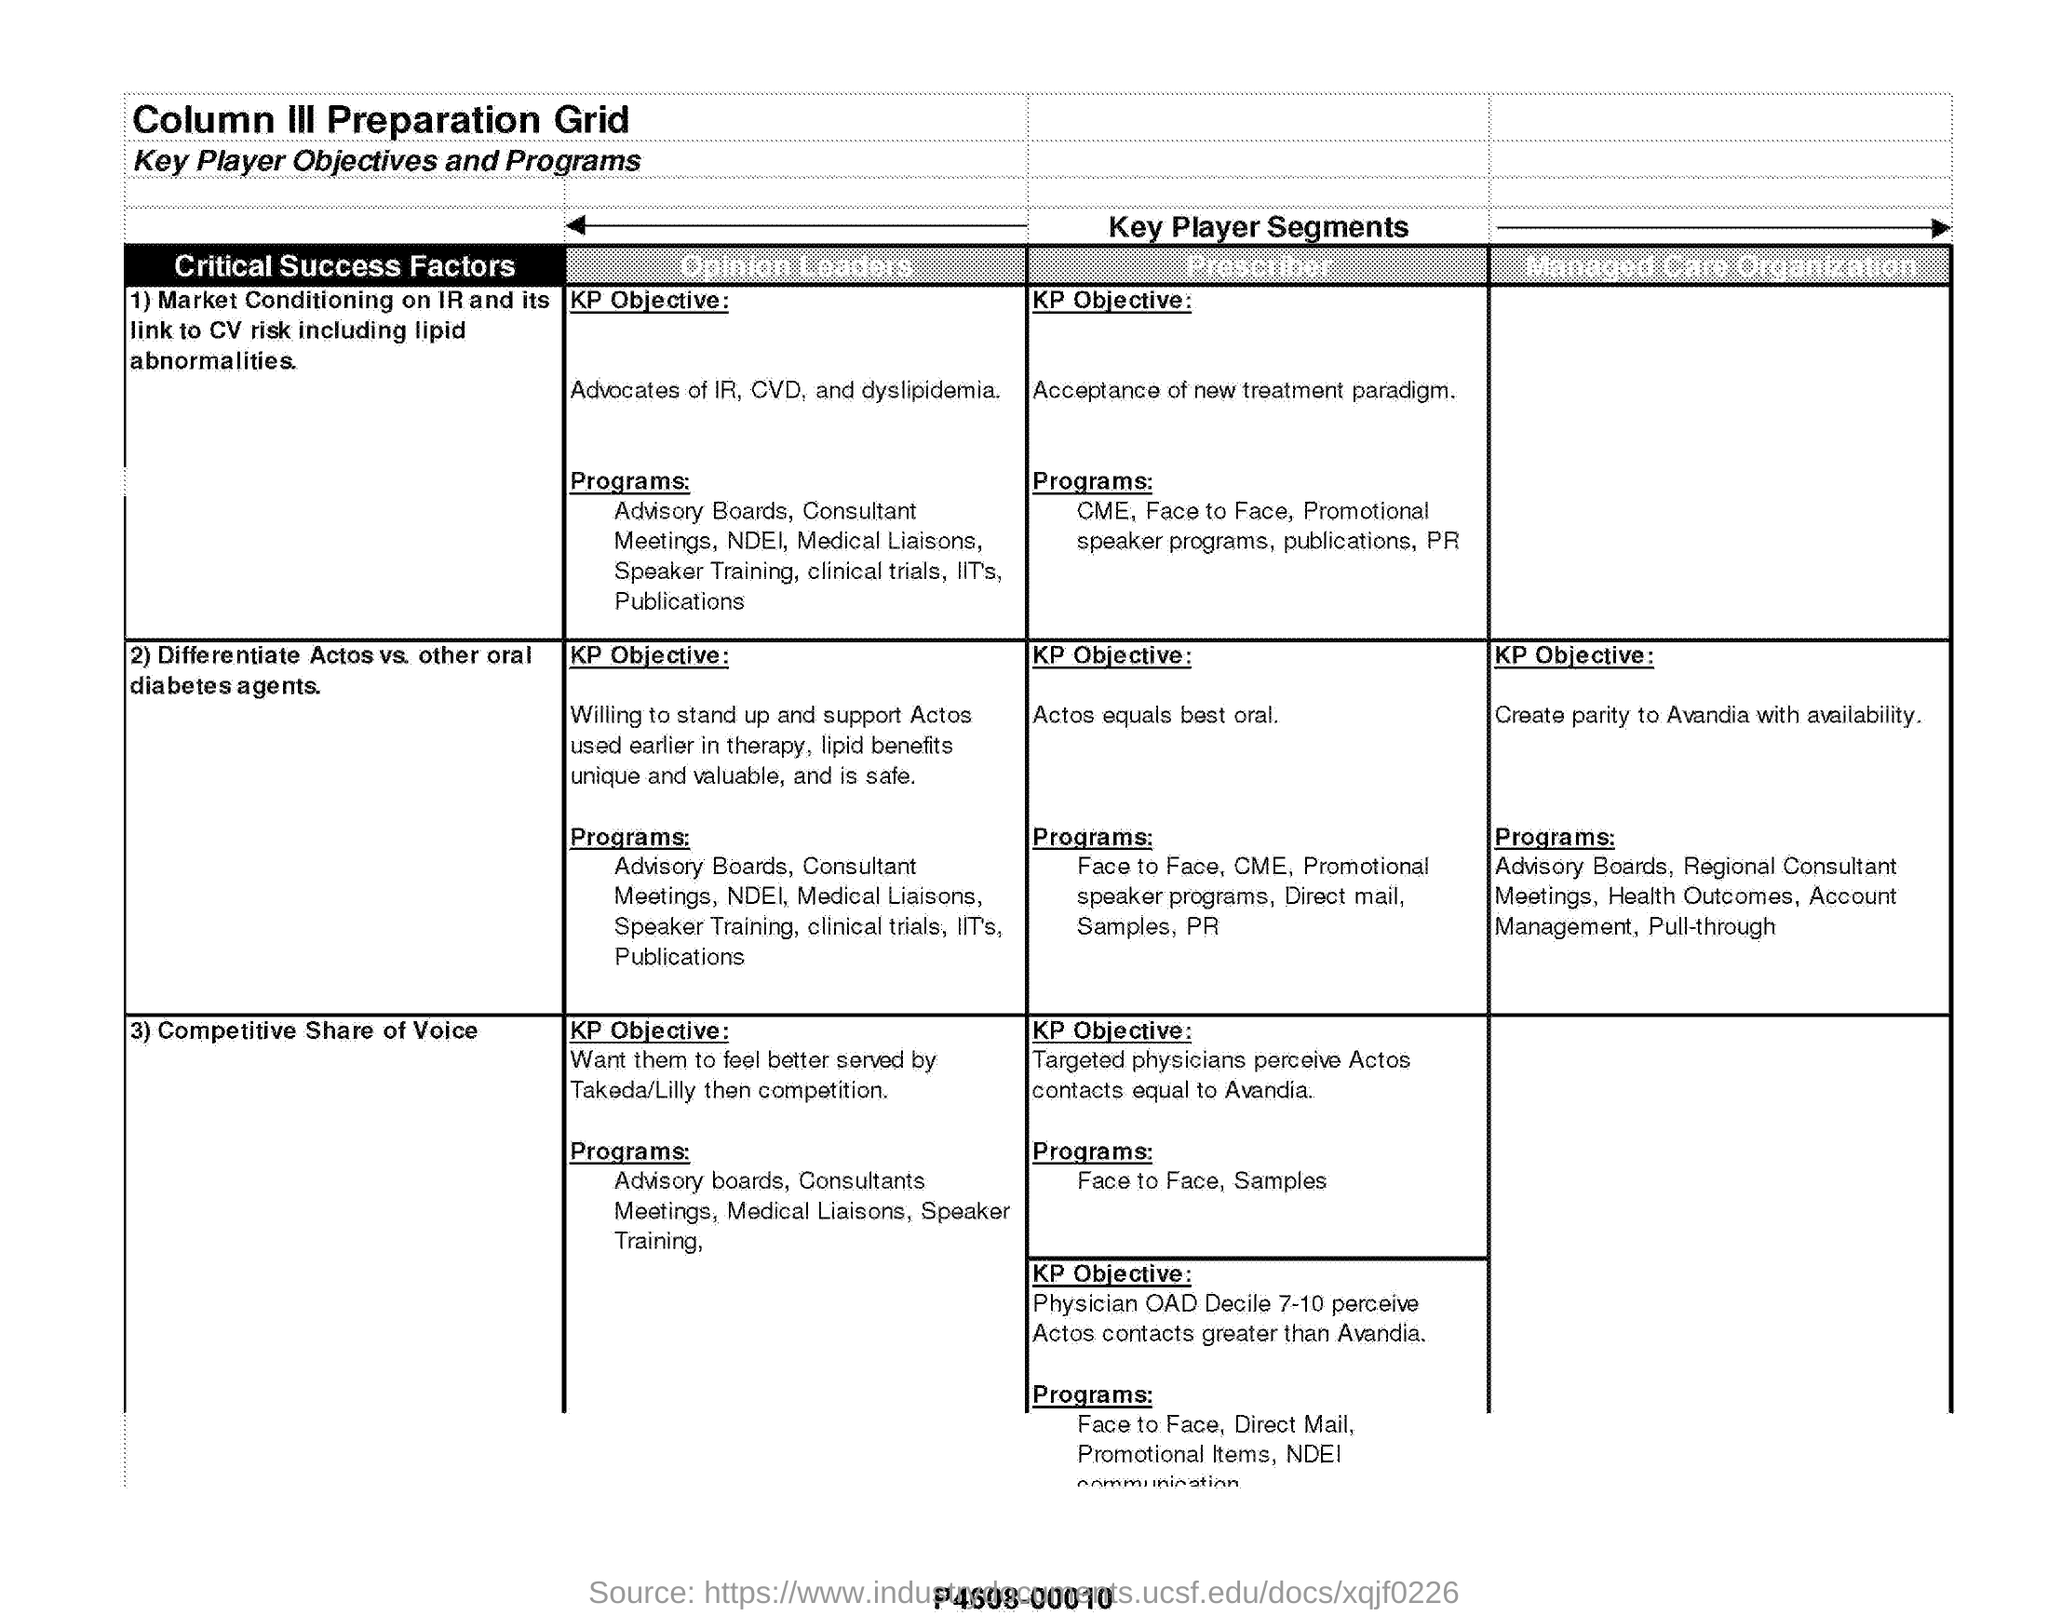What is the first column under Key Player Segments?
Keep it short and to the point. Critical Success Factors. What is the KP Objective of 'Prescriber' for the success factor 'Differentiate Actos vs. other oral diabetes agents'?
Make the answer very short. ACTOS EQUALS BEST ORAL. What is the third 'Critical Success Factors' mentioned in the document?
Keep it short and to the point. COMPETITIVE SHARE OF VOICE. 